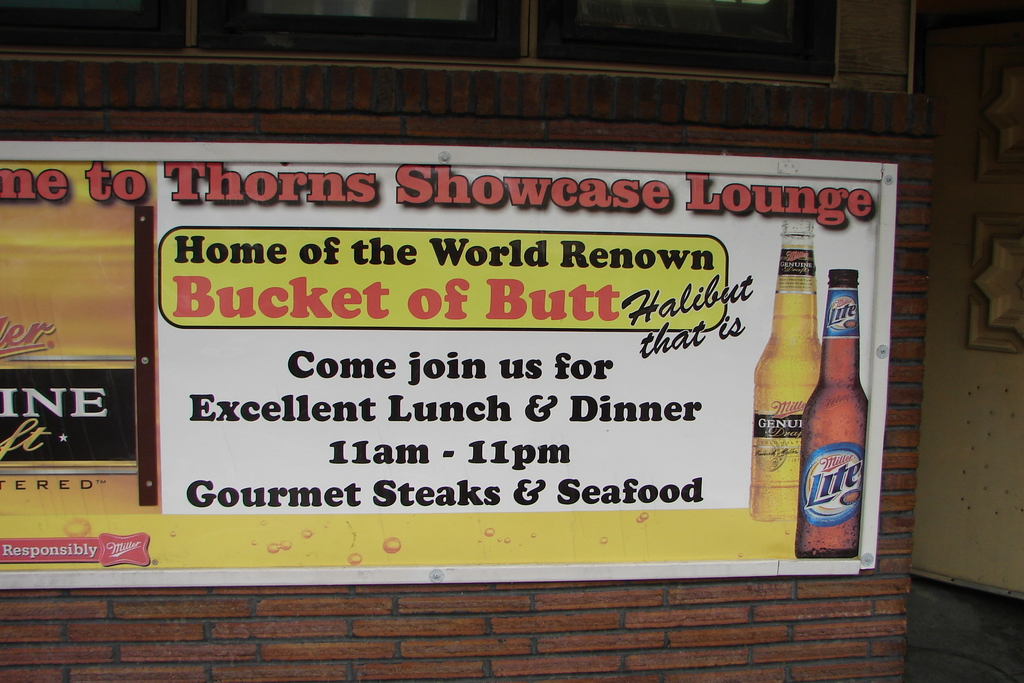What atmosphere does the design of the sign suggest about Thorns Showcase Lounge? The sign for Thorns Showcase Lounge features bright and bold text on a warm yellow background with playful imagery, suggesting a friendly and upbeat dining atmosphere. The inclusion of a beer bottle image also hints at a casual, perhaps jovial environment where diners can relax and enjoy a hearty meal. Does the sign mention any other food options available? Yes, along with their signature halibut, the sign advertises that the lounge serves gourmet steaks and seafood, indicating a versatile menu that caters to a variety of tastes and preferences. 